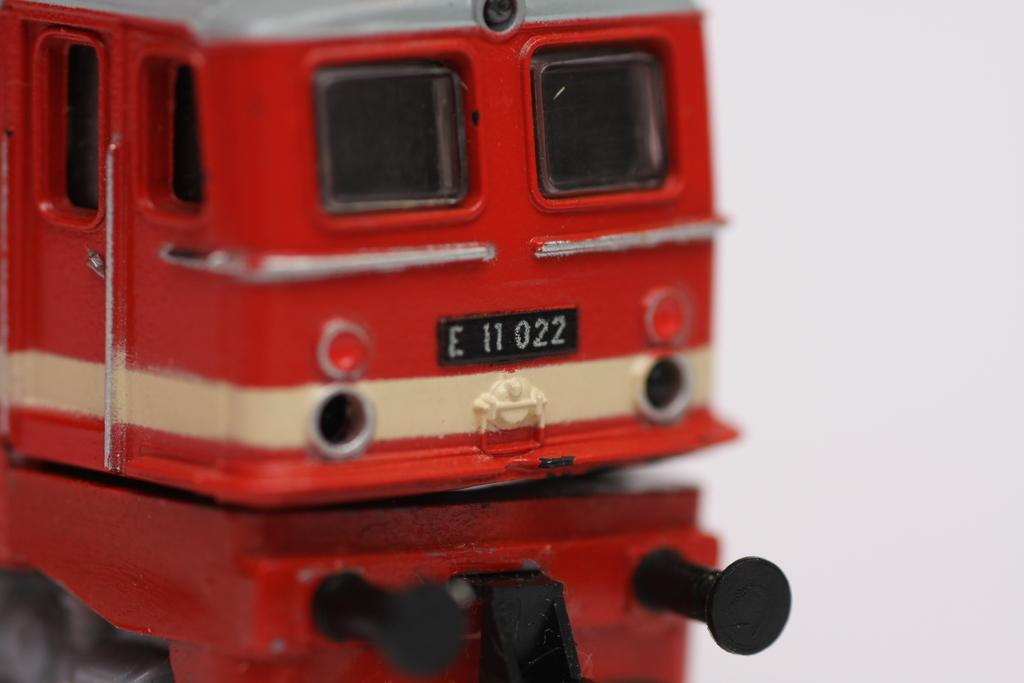<image>
Create a compact narrative representing the image presented. A model train has a license plate number E 11 022. 